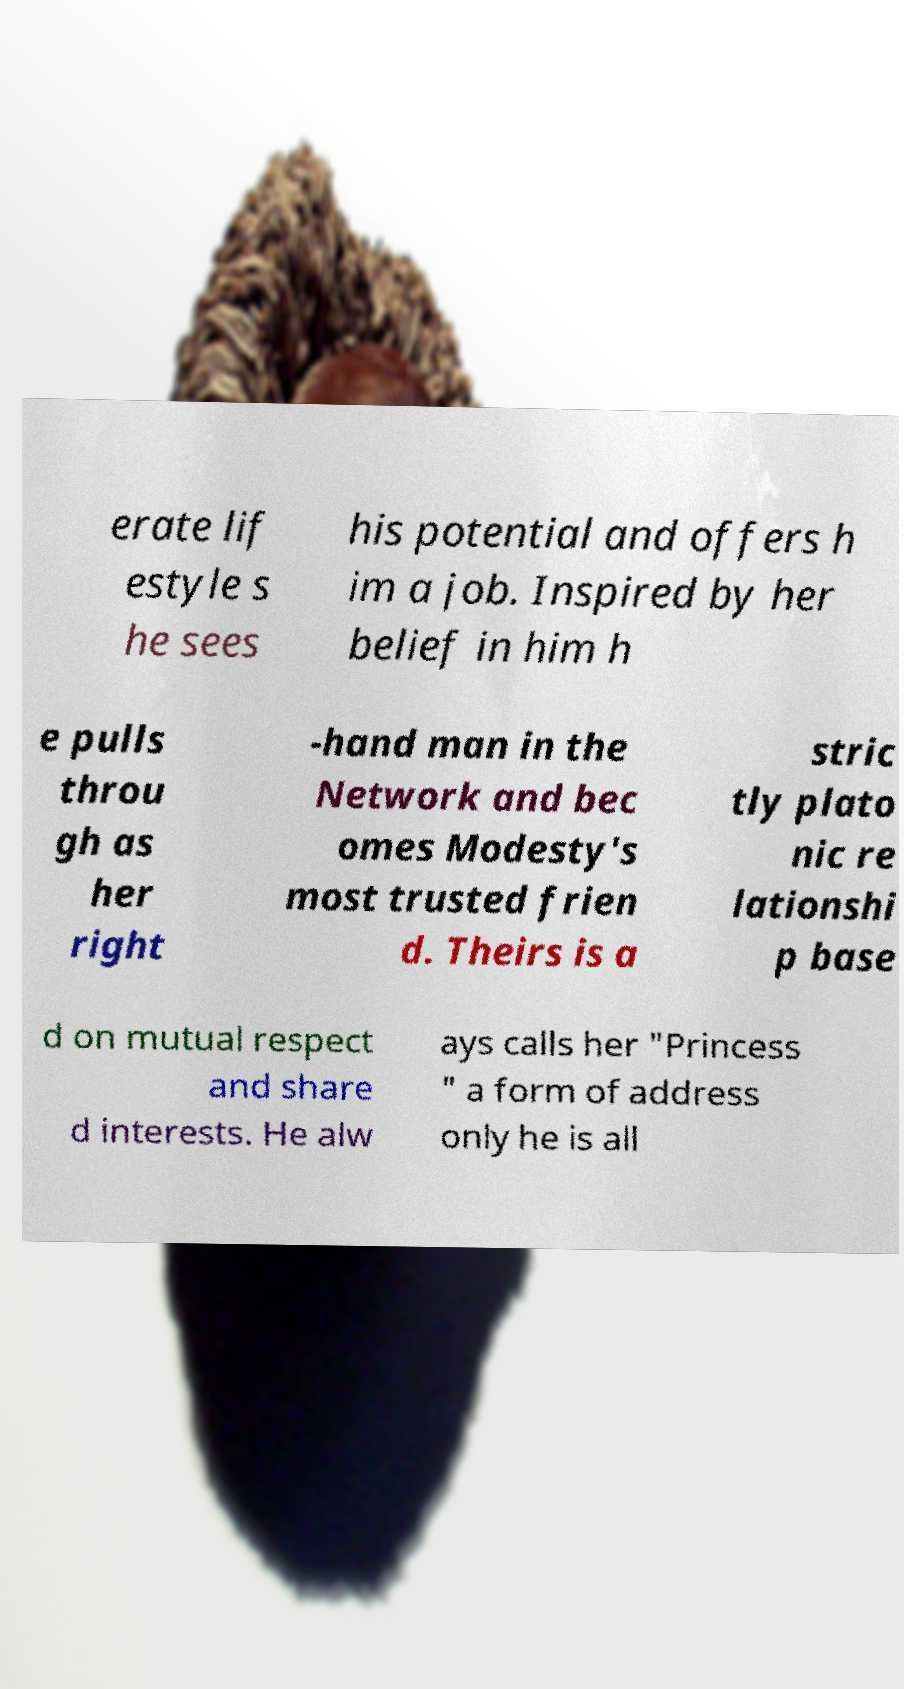Please read and relay the text visible in this image. What does it say? erate lif estyle s he sees his potential and offers h im a job. Inspired by her belief in him h e pulls throu gh as her right -hand man in the Network and bec omes Modesty's most trusted frien d. Theirs is a stric tly plato nic re lationshi p base d on mutual respect and share d interests. He alw ays calls her "Princess " a form of address only he is all 